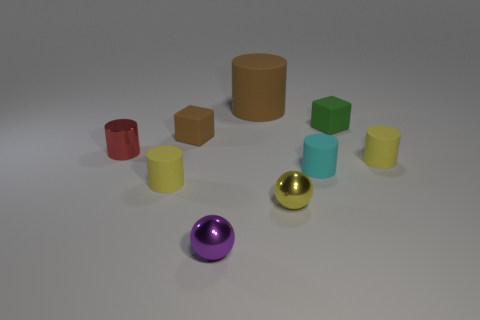Subtract all cyan rubber cylinders. How many cylinders are left? 4 Subtract all cyan cylinders. How many cylinders are left? 4 Subtract all balls. How many objects are left? 7 Subtract 1 balls. How many balls are left? 1 Subtract all gray spheres. Subtract all brown blocks. How many spheres are left? 2 Subtract 0 brown spheres. How many objects are left? 9 Subtract all cyan cylinders. How many brown blocks are left? 1 Subtract all purple things. Subtract all red cylinders. How many objects are left? 7 Add 5 cyan matte objects. How many cyan matte objects are left? 6 Add 5 large spheres. How many large spheres exist? 5 